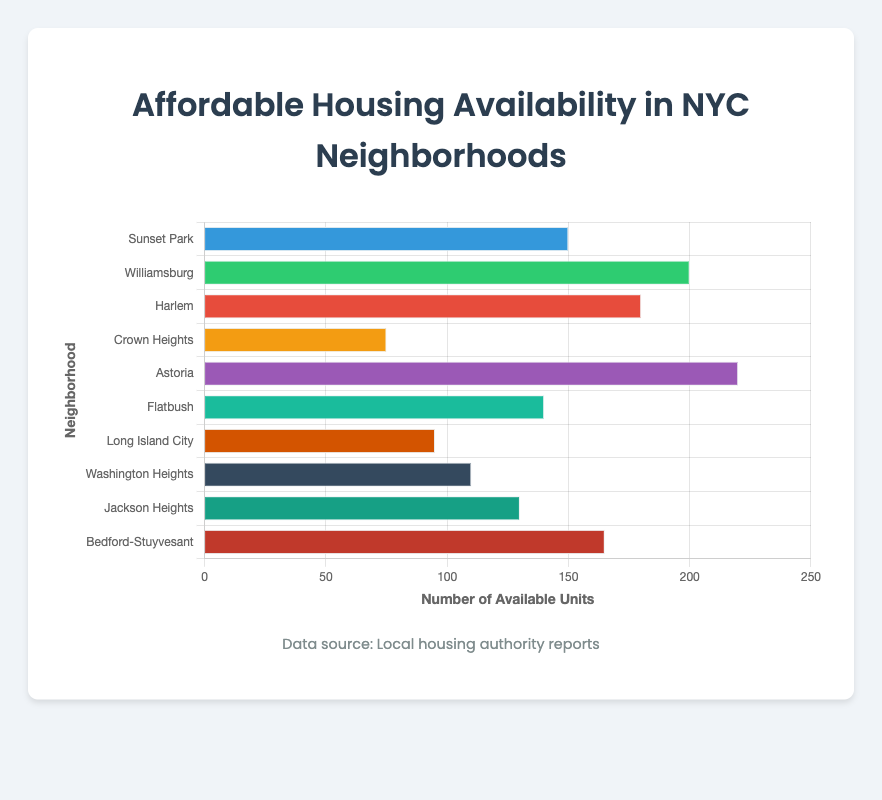Which neighborhood has the highest number of available affordable housing units? By comparing the heights of the horizontal bars, Astoria has the longest bar, indicating the highest number of available units at 220.
Answer: Astoria How many more units are available in Williamsburg compared to Crown Heights? Williamsburg has 200 units, while Crown Heights has 75 units. The difference is 200 - 75 = 125 units.
Answer: 125 What is the total number of available units in Harlem, Flatbush, and Jackson Heights combined? Summing the units: Harlem (180) + Flatbush (140) + Jackson Heights (130) gives 180 + 140 + 130 = 450 units.
Answer: 450 Which neighborhoods have fewer than 100 available affordable housing units? By checking the bars, Crown Heights (75) and Long Island City (95) have fewer than 100 units.
Answer: Crown Heights, Long Island City What is the ratio of available units in Sunset Park to those in Washington Heights? Sunset Park has 150 units, and Washington Heights has 110 units. The ratio is 150 / 110, which simplifies approximately to 1.36.
Answer: 1.36 Which neighborhood has a green-colored bar, and how many units are available there? By visual inspection, Williamsburg has a green-colored bar. The number of available units there is 200.
Answer: Williamsburg, 200 What is the average number of available affordable housing units across all neighborhoods? Sum all units: (150 + 200 + 180 + 75 + 220 + 140 + 95 + 110 + 130 + 165 = 1465). There are 10 neighborhoods, so the average is 1465 / 10 = 146.5 units.
Answer: 146.5 Are there more available units in Sunset Park and Flatbush combined than in Astoria alone? Sunset Park (150) + Flatbush (140) = 290 units, whereas Astoria has 220 units. 290 > 220, so the combined units are more.
Answer: Yes What color bar represents the neighborhood with the fewest available units, and how many units are there? By visual inspection, the neighborhood with the fewest units is Crown Heights, represented by an orange-colored bar, with 75 units.
Answer: Orange, 75 